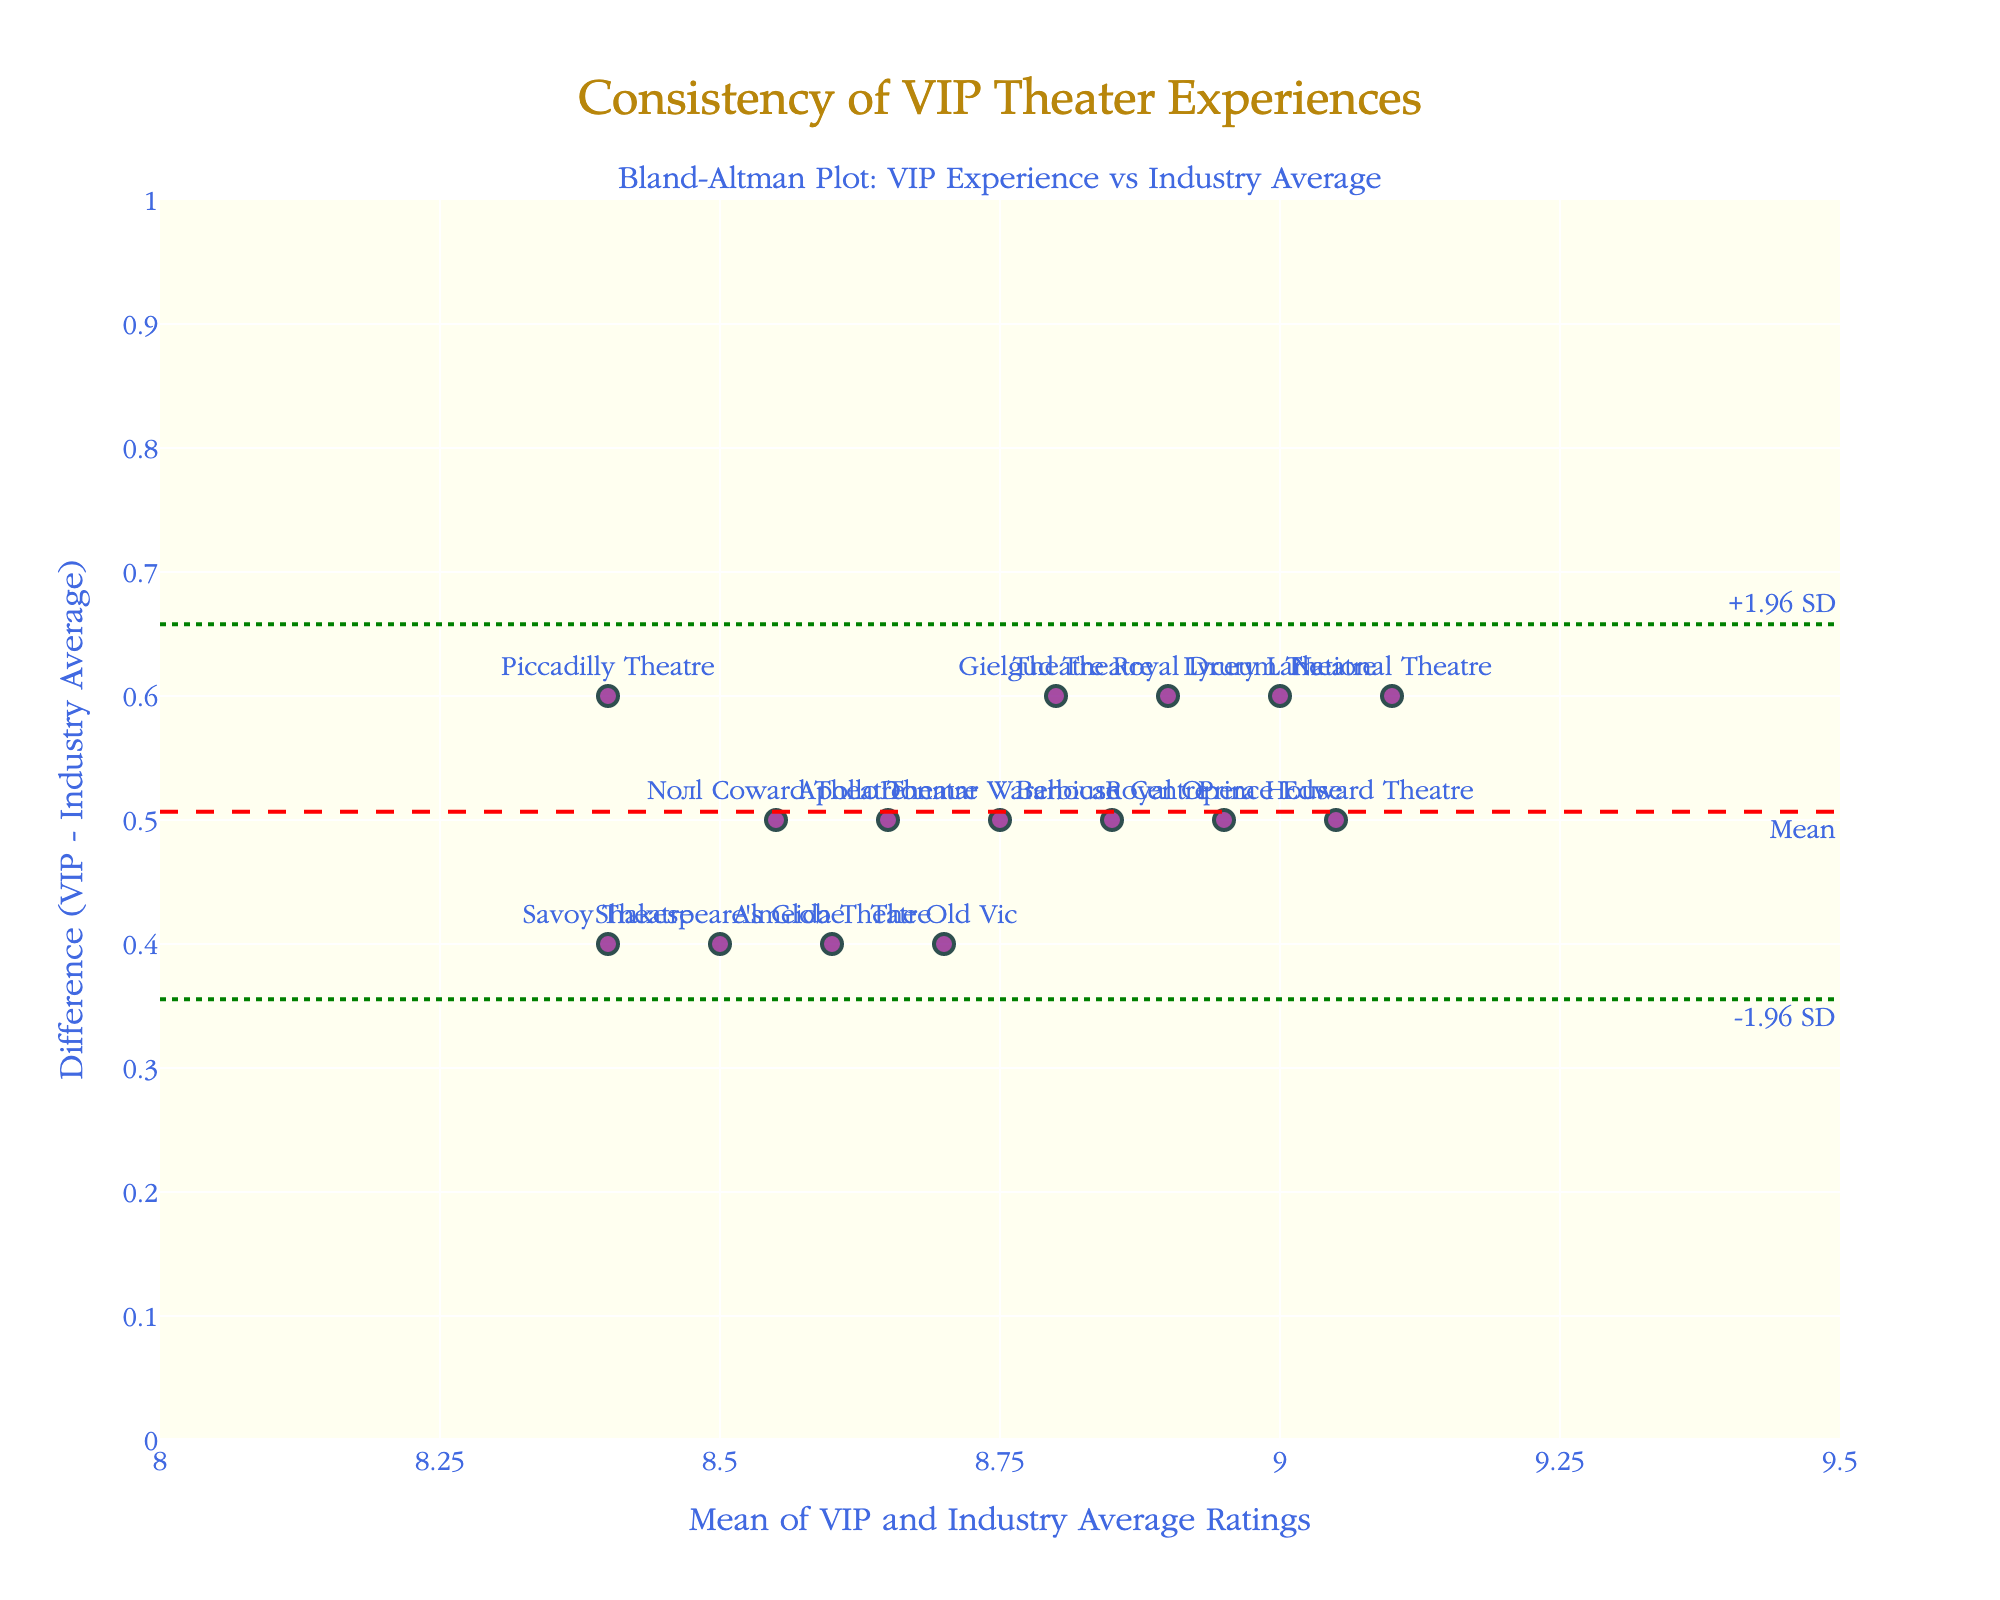What's the main title of the plot? The main title is positioned at the center-top and is used to describe the purpose of the plot. In this case, the title is "Consistency of VIP Theater Experiences".
Answer: Consistency of VIP Theater Experiences What does the x-axis represent? The x-axis title is labeled as "Mean of VIP and Industry Average Ratings," indicating that this axis represents the average of the VIP Experience Ratings and the Industry Average Ratings.
Answer: Mean of VIP and Industry Average Ratings How many theater data points are plotted? By observing the scatter plot, we can see the number of markers representing each theater. There are 15 theaters listed in the data set, and correspondingly, 15 markers are plotted on the figure.
Answer: 15 What are the upper and lower limits of agreement? The plot includes horizontal lines with annotations. The "+1.96 SD" and "-1.96 SD" lines indicate the limits of agreement. Each is positioned at y-values of approximately 0.775 and 0.155, respectively.
Answer: 0.775 and 0.155 Which theater has the highest mean rating between the VIP Experience and the Industry Average? We can determine the highest mean value by looking at the marker furthest to the right on the x-axis. The theater closest to the highest mean of combined ratings appears near a mean value of approximately 9.05, which corresponds to the Lyceum Theatre.
Answer: Lyceum Theatre Which theater has the largest difference between the VIP Experience Rating and the Industry Average Rating? The largest difference is indicated by the marker highest on the y-axis. The theater corresponding to the highest difference appears near a difference value of approximately 0.6 and a mean value of approximately 8.9, which is Shakespeare's Globe.
Answer: Shakespeare's Globe What is indicated by the red dashed line? The red dashed line represents the mean difference between the VIP Experience Ratings and the Industry Average Ratings. This line helps visualize whether there is a consistent bias towards VIP or Industry Ratings.
Answer: Mean difference What is the difference in ratings for the theater with the highest rating? The highest VIP Experience rating is 9.4 from the National Theatre. The Industry Average rating for this theater is 8.8. The difference is calculated as 9.4 - 8.8 = 0.6.
Answer: 0.6 Are there any theaters where the VIP Experience rating is lower than the Industry Average rating? By examining the y-axis values, if any data point is below zero, it indicates that the VIP rating is lower. In this Bland-Altman plot, all points are above zero, showing that VIP ratings are consistently higher.
Answer: No Which theater shows the smallest difference in rating? The smallest difference is indicated by the marker closest to the red dashed line (mean difference). The theater corresponding to the smallest difference (close to the mean value) is the Savoy Theatre with a difference close to 0.4.
Answer: Savoy Theatre 